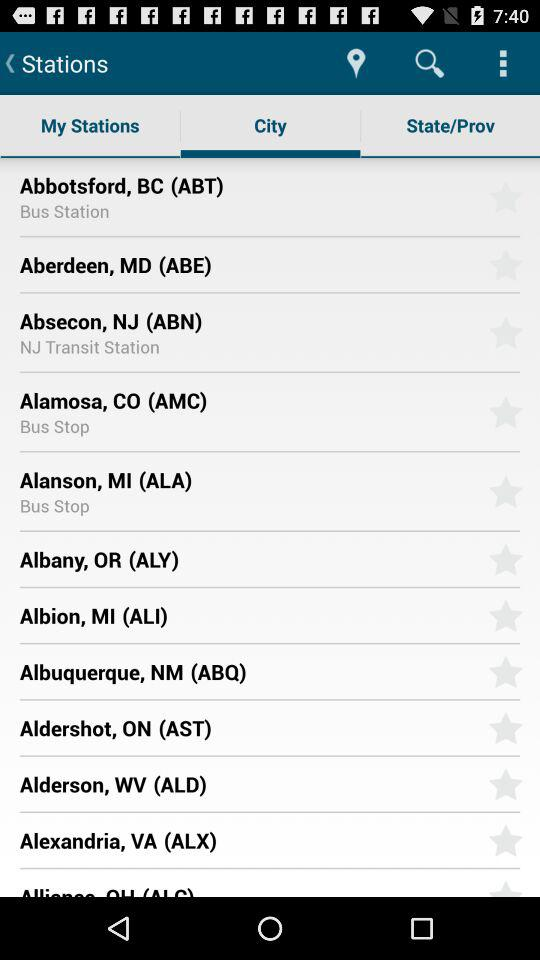Which tab is selected? The selected tab is "City". 